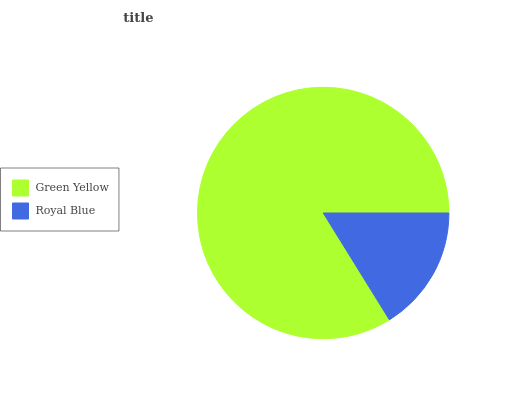Is Royal Blue the minimum?
Answer yes or no. Yes. Is Green Yellow the maximum?
Answer yes or no. Yes. Is Royal Blue the maximum?
Answer yes or no. No. Is Green Yellow greater than Royal Blue?
Answer yes or no. Yes. Is Royal Blue less than Green Yellow?
Answer yes or no. Yes. Is Royal Blue greater than Green Yellow?
Answer yes or no. No. Is Green Yellow less than Royal Blue?
Answer yes or no. No. Is Green Yellow the high median?
Answer yes or no. Yes. Is Royal Blue the low median?
Answer yes or no. Yes. Is Royal Blue the high median?
Answer yes or no. No. Is Green Yellow the low median?
Answer yes or no. No. 